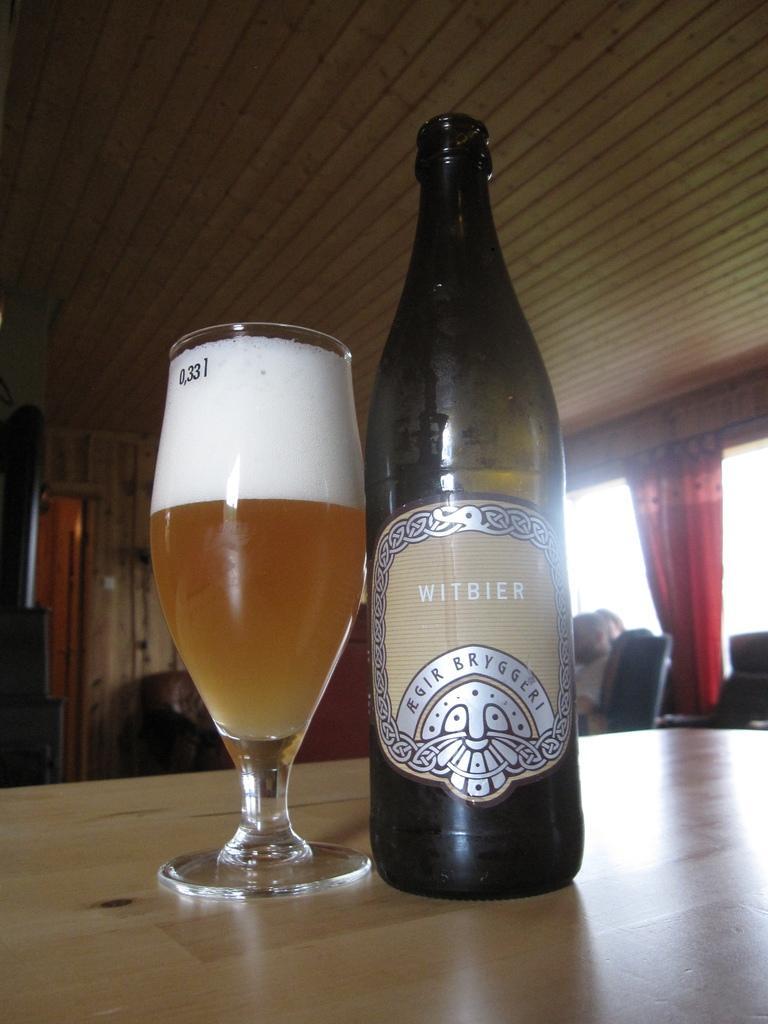Describe this image in one or two sentences. In this picture there is a bottle and a glass in the center of the image, on a table and there is a window with curtain on the right side of the image, there is a door on the left side of the image. 